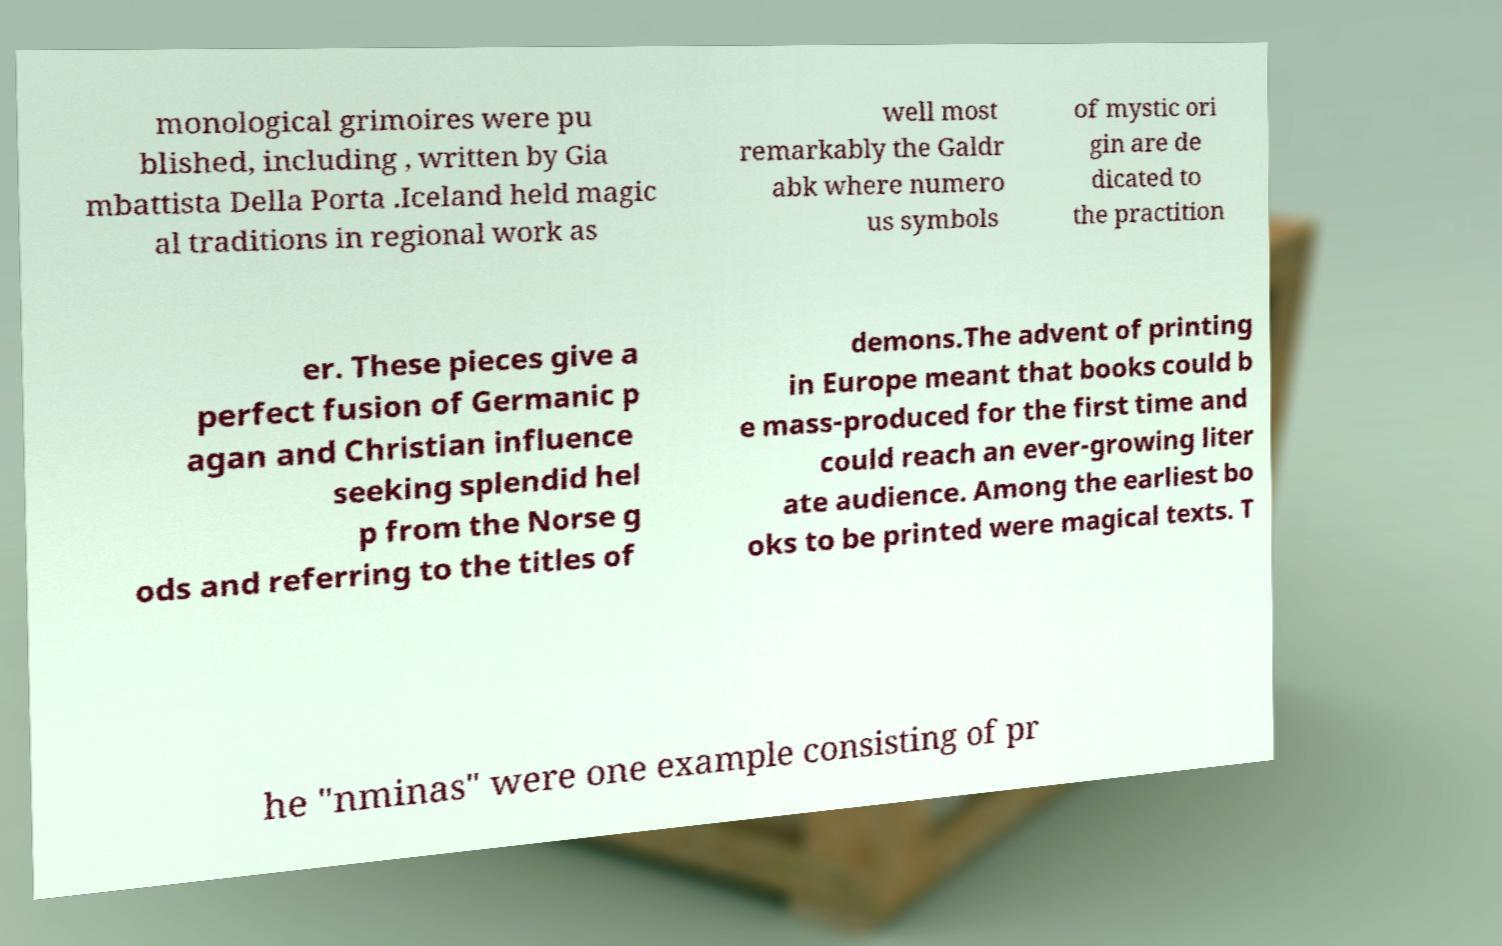Could you assist in decoding the text presented in this image and type it out clearly? monological grimoires were pu blished, including , written by Gia mbattista Della Porta .Iceland held magic al traditions in regional work as well most remarkably the Galdr abk where numero us symbols of mystic ori gin are de dicated to the practition er. These pieces give a perfect fusion of Germanic p agan and Christian influence seeking splendid hel p from the Norse g ods and referring to the titles of demons.The advent of printing in Europe meant that books could b e mass-produced for the first time and could reach an ever-growing liter ate audience. Among the earliest bo oks to be printed were magical texts. T he "nminas" were one example consisting of pr 